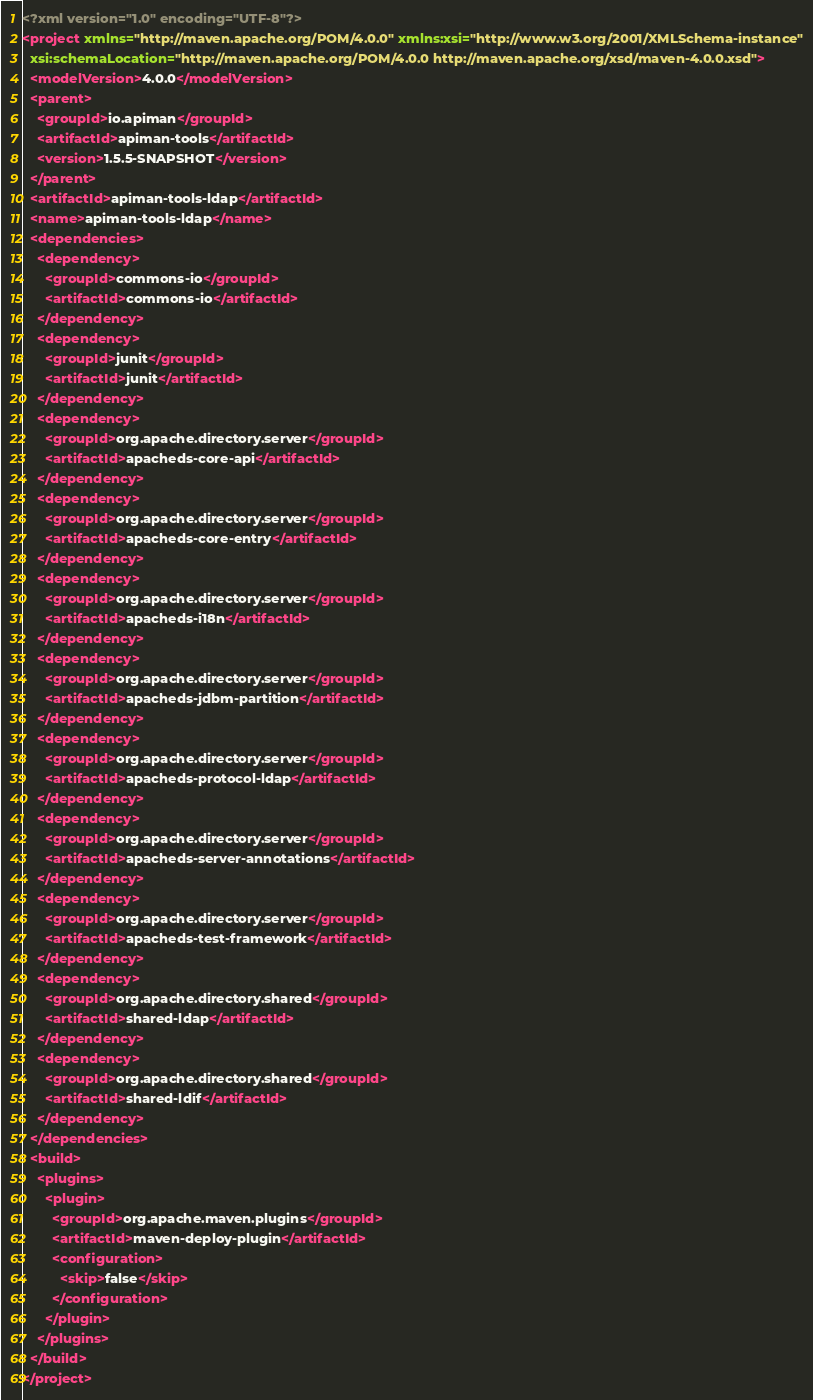<code> <loc_0><loc_0><loc_500><loc_500><_XML_><?xml version="1.0" encoding="UTF-8"?>
<project xmlns="http://maven.apache.org/POM/4.0.0" xmlns:xsi="http://www.w3.org/2001/XMLSchema-instance"
  xsi:schemaLocation="http://maven.apache.org/POM/4.0.0 http://maven.apache.org/xsd/maven-4.0.0.xsd">
  <modelVersion>4.0.0</modelVersion>
  <parent>
    <groupId>io.apiman</groupId>
    <artifactId>apiman-tools</artifactId>
    <version>1.5.5-SNAPSHOT</version>
  </parent>
  <artifactId>apiman-tools-ldap</artifactId>
  <name>apiman-tools-ldap</name>
  <dependencies>
    <dependency>
      <groupId>commons-io</groupId>
      <artifactId>commons-io</artifactId>
    </dependency>
    <dependency>
      <groupId>junit</groupId>
      <artifactId>junit</artifactId>
    </dependency>
    <dependency>
      <groupId>org.apache.directory.server</groupId>
      <artifactId>apacheds-core-api</artifactId>
    </dependency>
    <dependency>
      <groupId>org.apache.directory.server</groupId>
      <artifactId>apacheds-core-entry</artifactId>
    </dependency>
    <dependency>
      <groupId>org.apache.directory.server</groupId>
      <artifactId>apacheds-i18n</artifactId>
    </dependency>
    <dependency>
      <groupId>org.apache.directory.server</groupId>
      <artifactId>apacheds-jdbm-partition</artifactId>
    </dependency>
    <dependency>
      <groupId>org.apache.directory.server</groupId>
      <artifactId>apacheds-protocol-ldap</artifactId>
    </dependency>
    <dependency>
      <groupId>org.apache.directory.server</groupId>
      <artifactId>apacheds-server-annotations</artifactId>
    </dependency>
    <dependency>
      <groupId>org.apache.directory.server</groupId>
      <artifactId>apacheds-test-framework</artifactId>
    </dependency>
    <dependency>
      <groupId>org.apache.directory.shared</groupId>
      <artifactId>shared-ldap</artifactId>
    </dependency>
    <dependency>
      <groupId>org.apache.directory.shared</groupId>
      <artifactId>shared-ldif</artifactId>
    </dependency>
  </dependencies>
  <build>
    <plugins>
      <plugin>
        <groupId>org.apache.maven.plugins</groupId>
        <artifactId>maven-deploy-plugin</artifactId>
        <configuration>
          <skip>false</skip>
        </configuration>
      </plugin>
    </plugins>
  </build>
</project>
</code> 